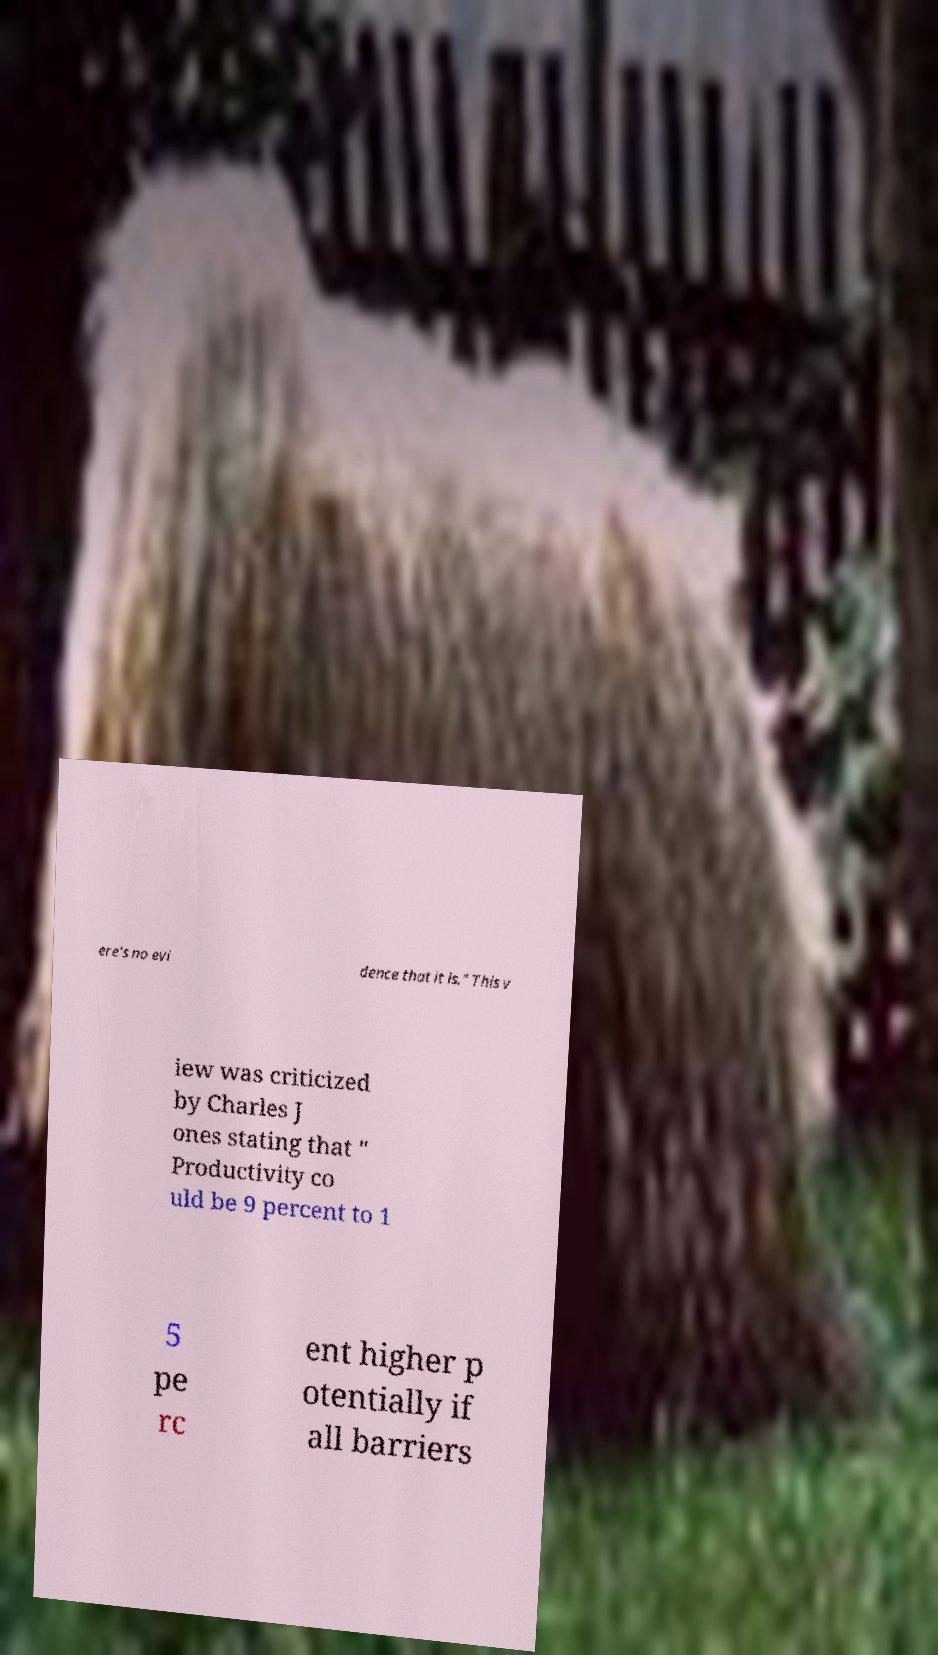Could you extract and type out the text from this image? ere's no evi dence that it is." This v iew was criticized by Charles J ones stating that " Productivity co uld be 9 percent to 1 5 pe rc ent higher p otentially if all barriers 